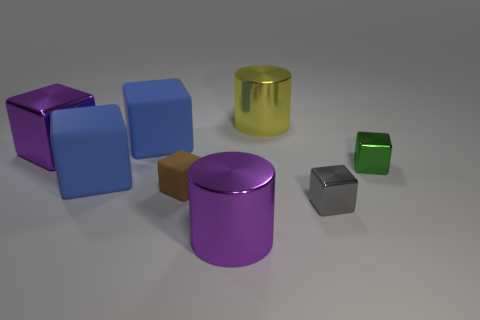There is a metallic block that is both behind the tiny matte cube and right of the large purple metal block; how big is it?
Your answer should be compact. Small. The big metal cube is what color?
Provide a succinct answer. Purple. How many green cubes are there?
Keep it short and to the point. 1. How many metallic cylinders are the same color as the big metal block?
Offer a terse response. 1. Is the shape of the big purple thing behind the green shiny object the same as the object that is in front of the gray metallic thing?
Your response must be concise. No. What color is the cylinder behind the brown matte cube behind the small thing in front of the brown matte block?
Make the answer very short. Yellow. The small cube that is left of the purple cylinder is what color?
Offer a very short reply. Brown. What is the color of the matte cube that is the same size as the gray thing?
Provide a succinct answer. Brown. Is the size of the purple metal cylinder the same as the brown thing?
Your answer should be very brief. No. What number of brown things are to the right of the brown block?
Ensure brevity in your answer.  0. 